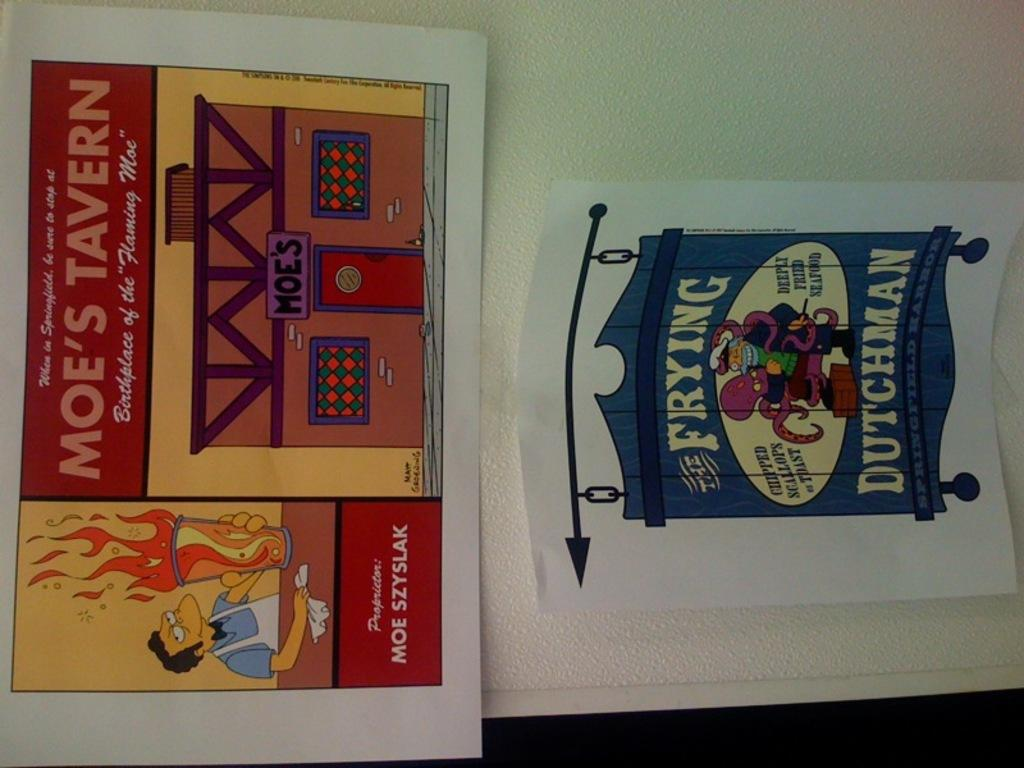<image>
Render a clear and concise summary of the photo. A picture showing More's Tavern from the show The Simpsons hangs on a wall above a picture with a Frying Dutchman sign. 